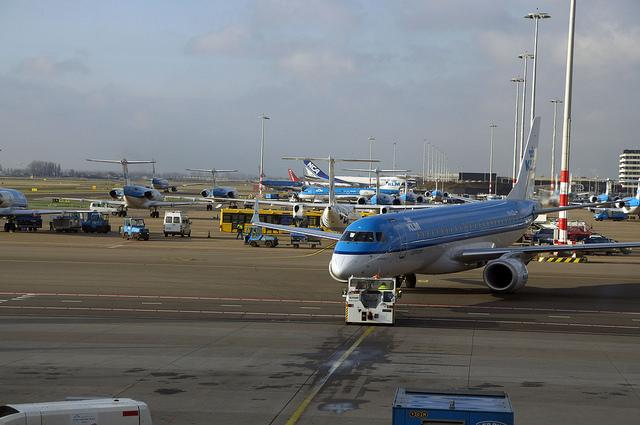What is the circular object under the wing? Please explain your reasoning. jet engine. The circular object under the wing signifies this is a jet engine operated aircraft. 